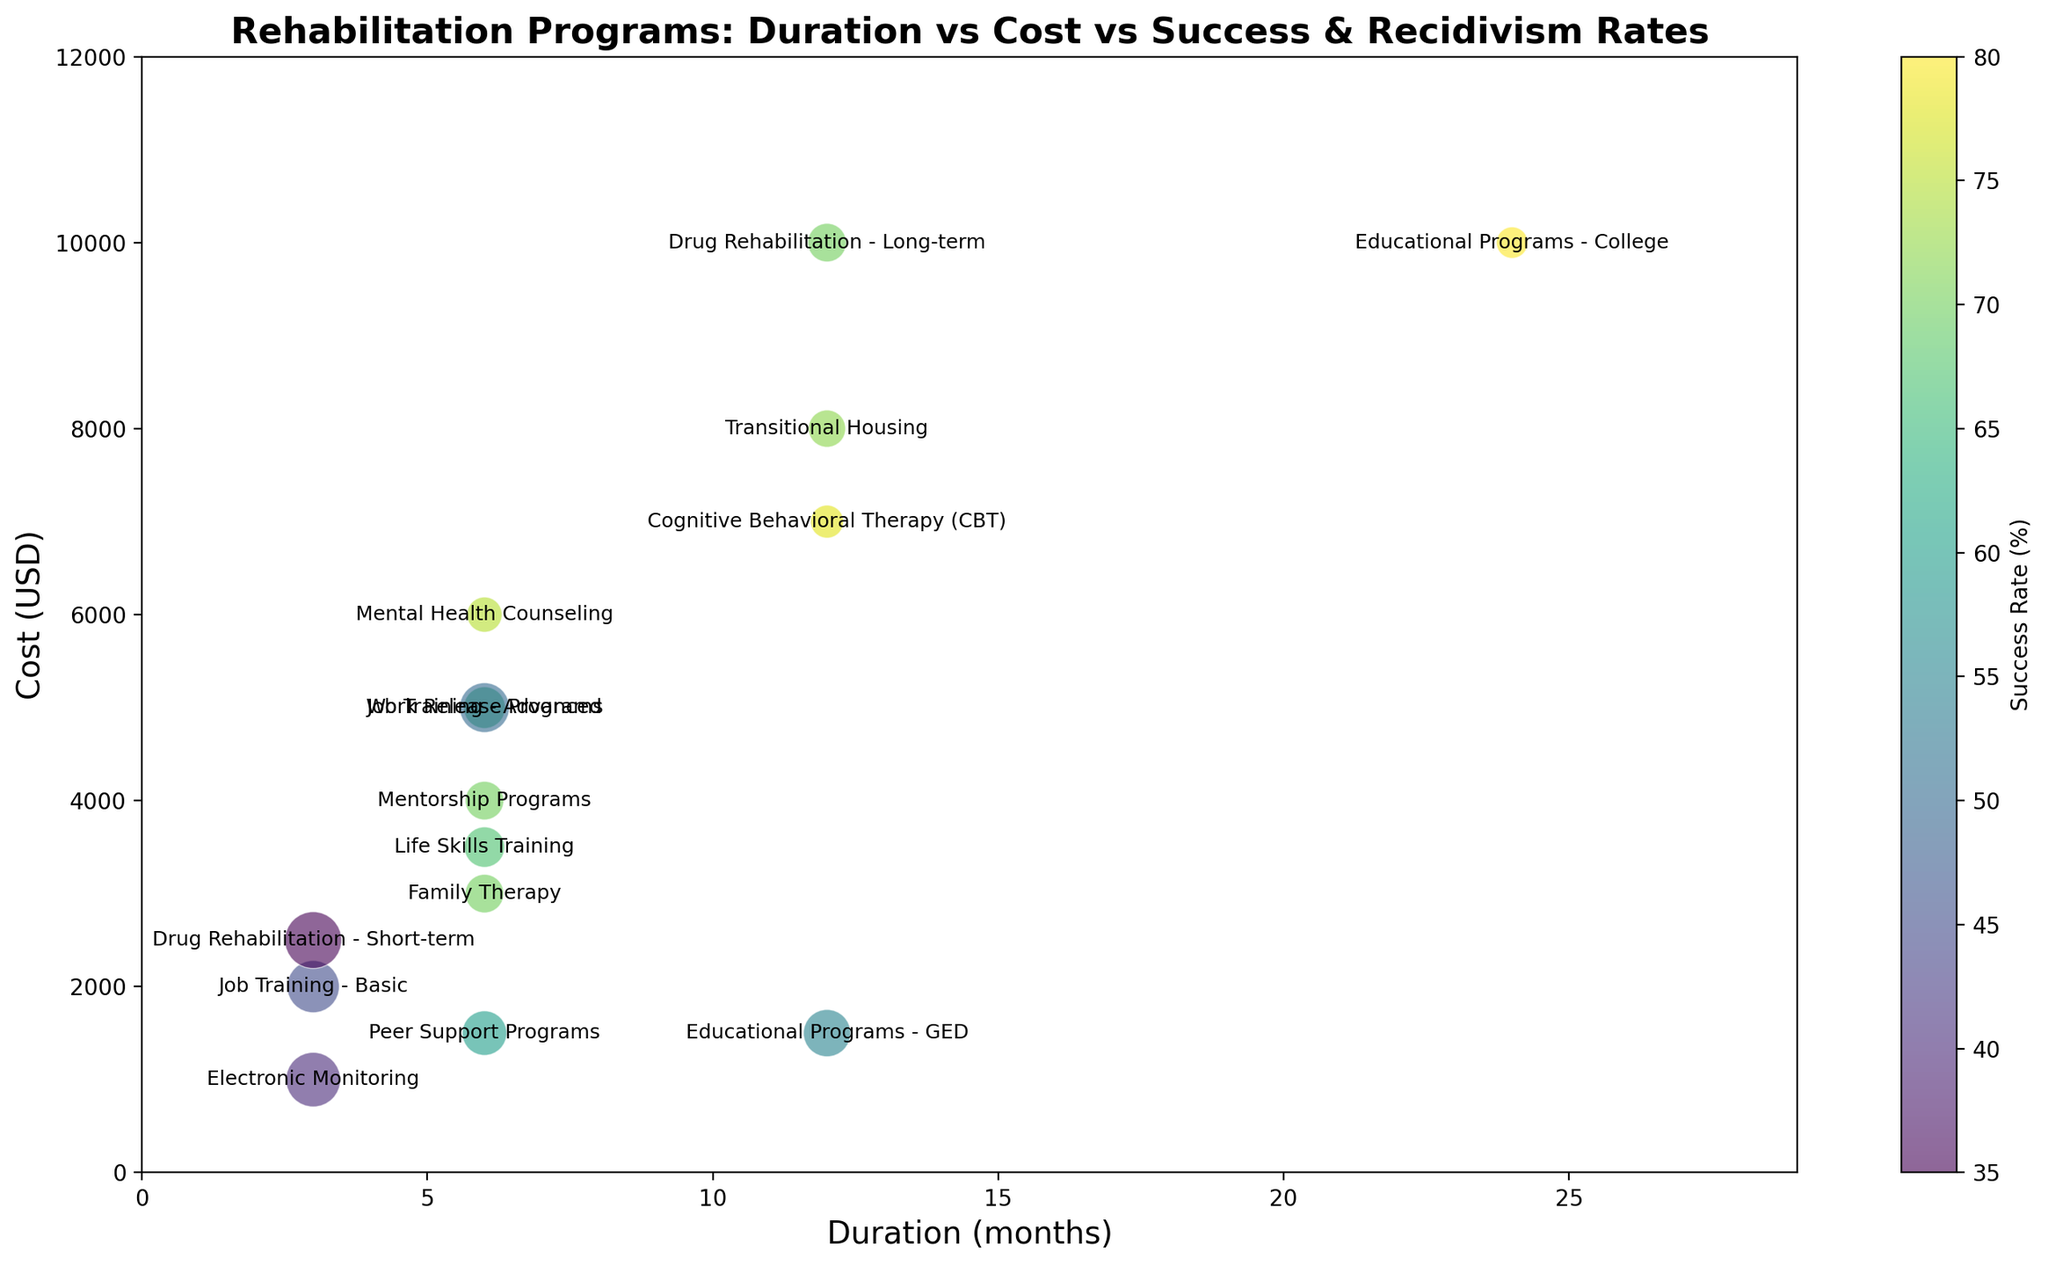What's the duration and cost of the program with the highest success rate? The program with the highest success rate is 'Educational Programs - College' which is denoted by the darkest color bubble. By looking at the x-axis and y-axis values for this bubble, the duration is 24 months and the cost is $10,000.
Answer: 24 months, $10,000 Which program has the lowest recidivism rate and what are its success rate and duration? To find the program with the lowest recidivism rate, look for the smallest bubble. The smallest bubble represents 'Educational Programs - College'. Its success rate is 80%, and its duration is 24 months.
Answer: 80%, 24 months Between 'Job Training - Basic' and 'Job Training - Advanced', which has a higher success rate and what is the difference? 'Job Training - Advanced' has a success rate of 65%, whereas 'Job Training - Basic' has a success rate of 45%. The difference between them is 65% - 45% = 20%.
Answer: Job Training - Advanced, 20% What is the median duration of all the programs plotted? To find the median duration, list all durations in ascending order: 3, 3, 3, 6, 6, 6, 6, 6, 6, 12, 12, 12, 12, 24. The median is the average of the 7th and 8th values in this list: (6 + 6) / 2 = 6.
Answer: 6 months Which program has a higher cost: 'Cognitive Behavioral Therapy (CBT)' or 'Family Therapy'? By looking at the y-axis, 'Cognitive Behavioral Therapy (CBT)' has a cost of $7,000 which is higher than 'Family Therapy' with a cost of $3,000.
Answer: Cognitive Behavioral Therapy (CBT) Which program has the highest recidivism rate and what is its success rate? The program with the highest recidivism rate is 'Drug Rehabilitation - Short-term', which has a recidivism rate of 65%. Its success rate is 35%.
Answer: 35% What is the success rate of the cheapest program and what is its duration? The cheapest program is 'Electronic Monitoring' costing $1,000. Its success rate is 40%, and its duration is 3 months.
Answer: 40%, 3 months Among programs that last for 12 months, which has the lowest cost and what is its success rate? The programs lasting 12 months are 'Educational Programs - GED', 'Drug Rehabilitation - Long-term', 'Cognitive Behavioral Therapy (CBT)', and 'Transitional Housing'. The program with the lowest cost is 'Educational Programs - GED' at $1,500, and its success rate is 55%.
Answer: Educational Programs - GED, 55% What is the average cost of programs with a duration of 6 months? To find the average cost, sum the costs of all 6-month programs: $5000 (Job Training - Advanced) + $6000 (Mental Health Counseling) + $3000 (Family Therapy) + $1500 (Peer Support Programs) + $5000 (Work Release Programs) + $4000 (Mentorship Programs) + $3500 (Life Skills Training) = $29000. There are 7 programs, so the average cost is $29000 / 7 = $4,142.86.
Answer: $4,142.86 Which program has the highest success rate among those costing more than $5,000? Among programs costing more than $5,000, 'Educational Programs - College', 'Drug Rehabilitation - Long-term', 'Mental Health Counseling', 'Cognitive Behavioral Therapy (CBT)', and 'Transitional Housing' are candidates. The highest rate among these is 'Educational Programs - College' with 80%.
Answer: Educational Programs - College 